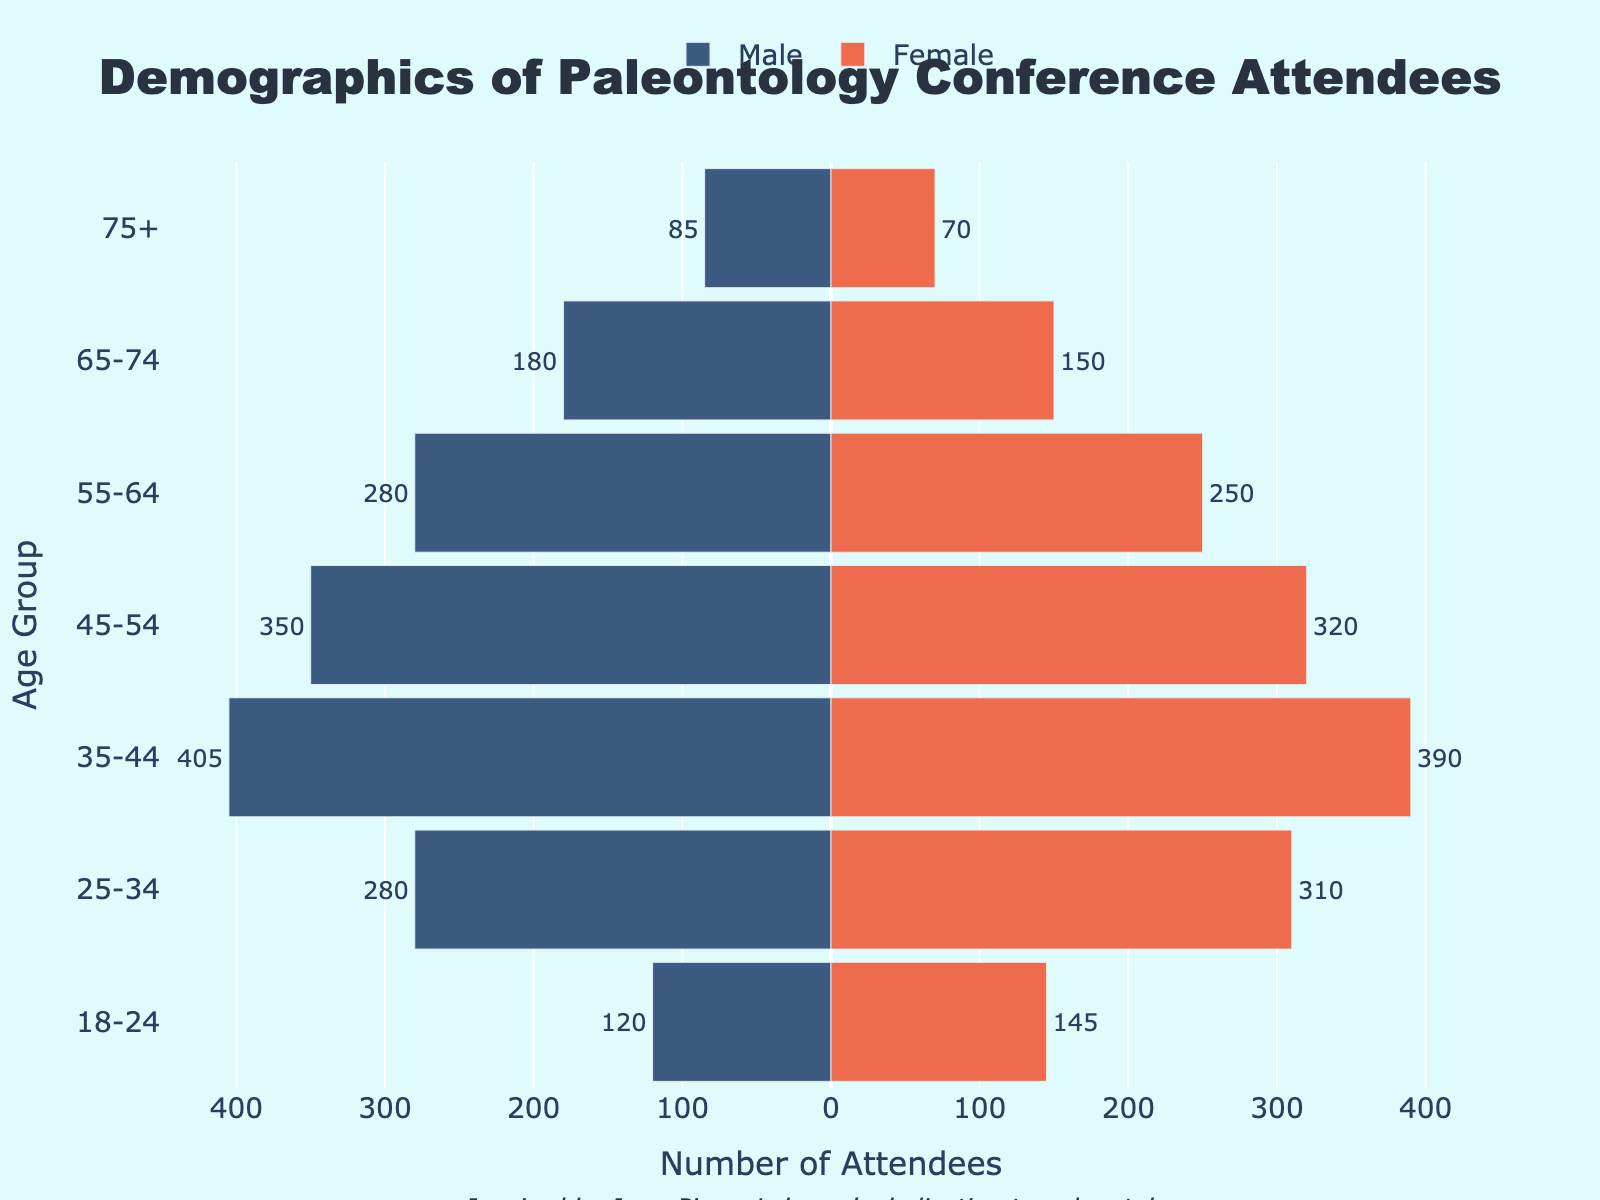What is the age group with the highest number of male attendees? The age group with the highest number of male attendees can be found by looking at the largest negative bar in the male section. The male bar for the 35-44 age group has the largest negative value at -405.
Answer: 35-44 What is the total number of female attendees in the age groups 55-64 and 65-74? To calculate the total, add the number of female attendees in both age groups. For 55-64, there are 250 females, and for 65-74, there are 150. Therefore, 250 + 150 = 400.
Answer: 400 Which age group shows a higher number of male attendees than female attendees? Compare the height of the bars for both male and female in each age group. The age group 35-44 shows 405 males and 390 females.
Answer: 35-44 What is the difference in the number of attendees between males in the 18-24 age group and females in the same age group? To find the difference, subtract the number of males from the number of females in the 18-24 age group. Therefore, 145 (females) - 120 (males) = 25.
Answer: 25 What is the total number of attendees in the 25-34 age group? Sum the male and female attendees in the 25-34 age group. So, 280 (males) + 310 (females) = 590.
Answer: 590 Do males or females constitute a majority in the 45-54 age group? Compare the number of attendees for males and females in the 45-54 age group. There are 350 males and 320 females, so males constitute the majority.
Answer: Males What is the ratio of female attendees to male attendees in the 65-74 age group? The ratio can be found by dividing the number of female attendees by the number of male attendees in the 65-74 age group. Therefore, 150 / 180 = 0.83 (to two decimal places).
Answer: 0.83 How many total attendees belong to the age group 75+? Add the number of males and females in the 75+ age group. Thus, 85 (males) + 70 (females) = 155.
Answer: 155 